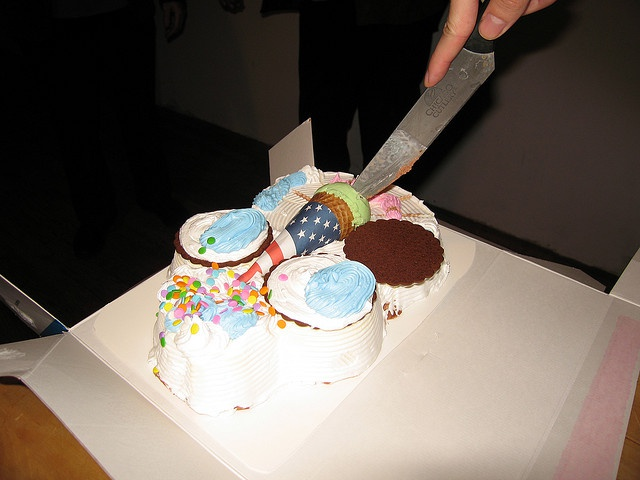Describe the objects in this image and their specific colors. I can see cake in black, white, maroon, lightblue, and tan tones, knife in black, gray, and darkgray tones, and people in black, brown, and salmon tones in this image. 